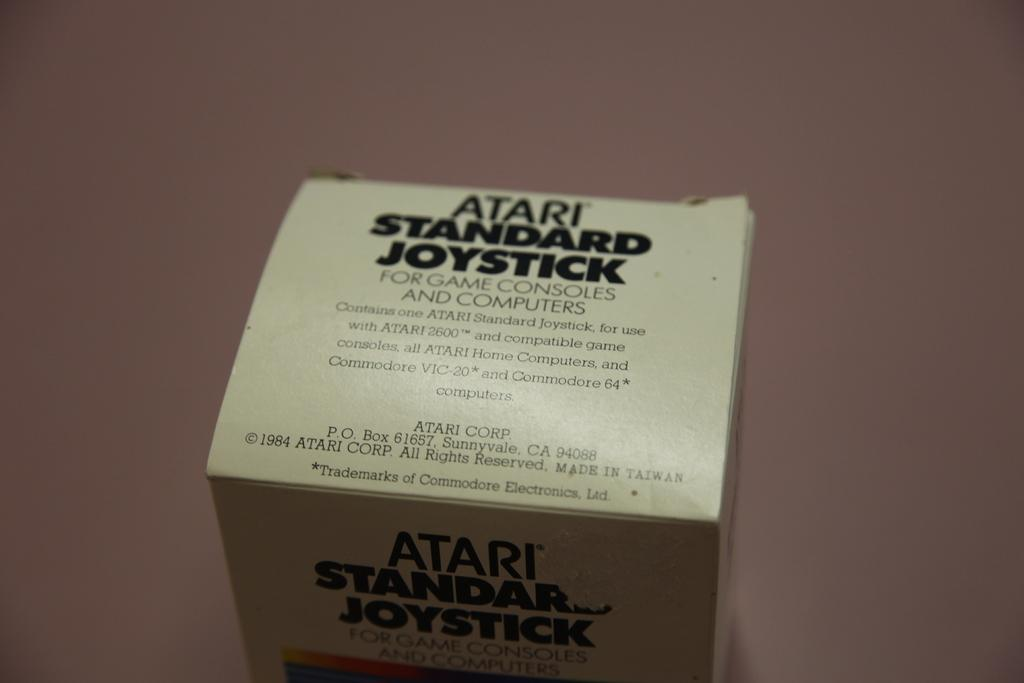<image>
Describe the image concisely. a small box that has black lettering on it that says 'atari standard joystick' 